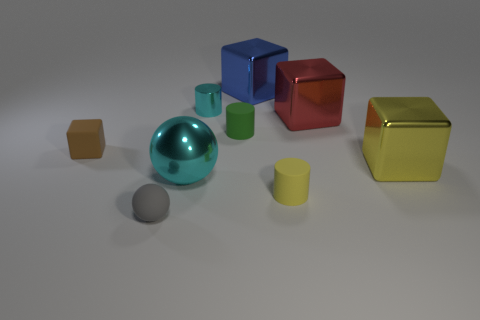Subtract all tiny matte cylinders. How many cylinders are left? 1 Subtract all green objects. Subtract all rubber objects. How many objects are left? 4 Add 4 yellow blocks. How many yellow blocks are left? 5 Add 3 big brown shiny cubes. How many big brown shiny cubes exist? 3 Subtract all blue cubes. How many cubes are left? 3 Subtract 1 red cubes. How many objects are left? 8 Subtract all spheres. How many objects are left? 7 Subtract 2 blocks. How many blocks are left? 2 Subtract all blue cylinders. Subtract all yellow spheres. How many cylinders are left? 3 